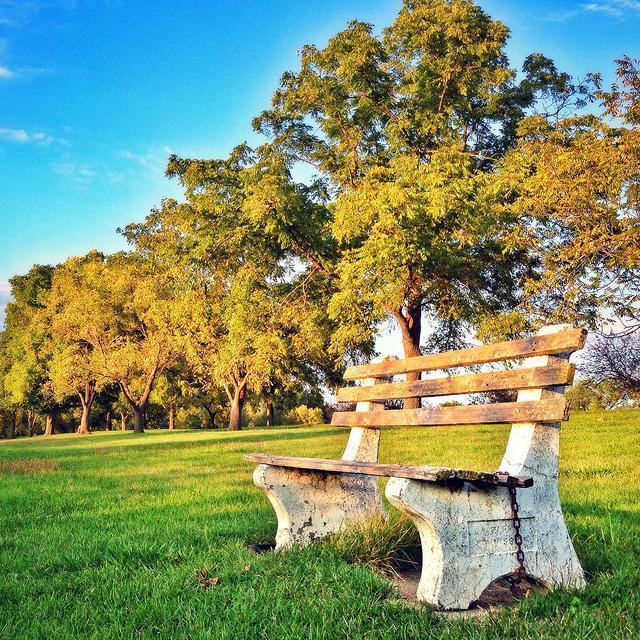How many people are on the bench?
Give a very brief answer. 0. 